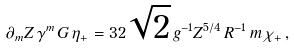Convert formula to latex. <formula><loc_0><loc_0><loc_500><loc_500>\partial _ { m } Z \, \gamma ^ { m } \, G \, \eta _ { + } = 3 2 \sqrt { 2 } \, g ^ { - 1 } Z ^ { 5 / 4 } \, R ^ { - 1 } \, m \, \chi _ { + } \, ,</formula> 